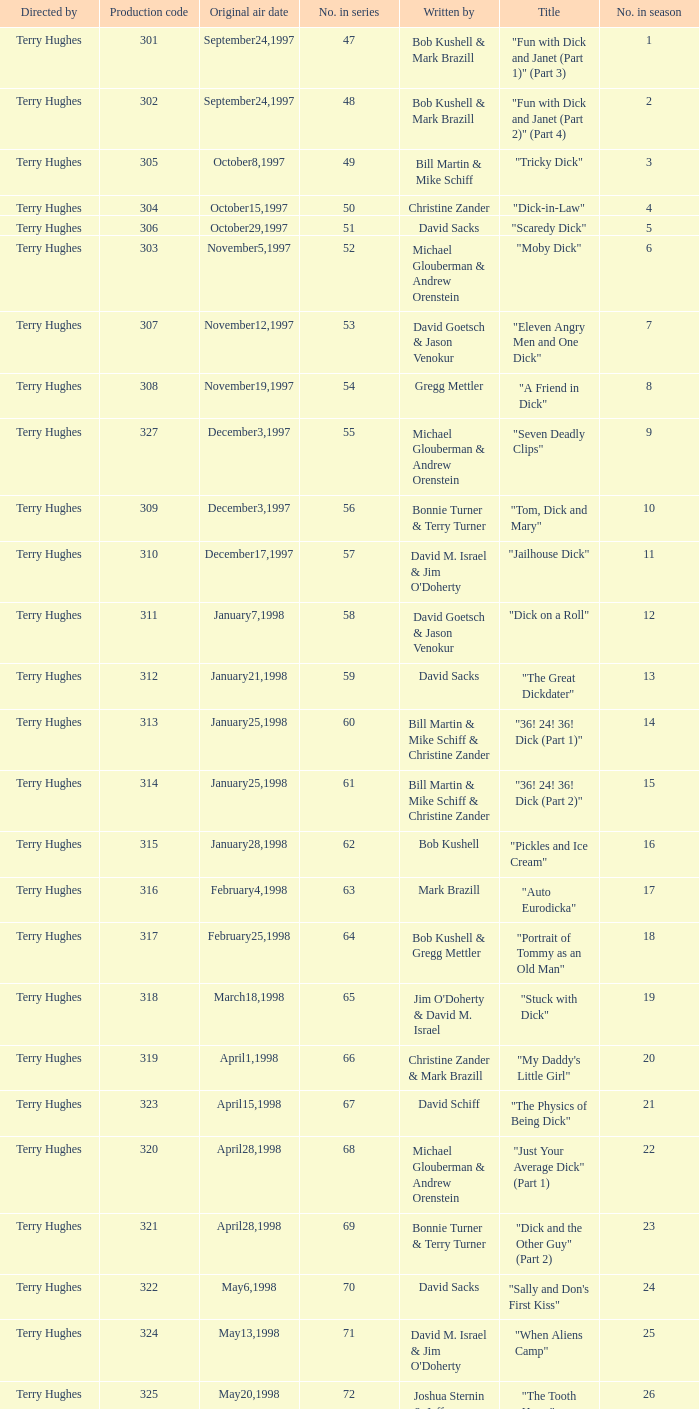Who were the writers of the episode titled "Tricky Dick"? Bill Martin & Mike Schiff. Can you give me this table as a dict? {'header': ['Directed by', 'Production code', 'Original air date', 'No. in series', 'Written by', 'Title', 'No. in season'], 'rows': [['Terry Hughes', '301', 'September24,1997', '47', 'Bob Kushell & Mark Brazill', '"Fun with Dick and Janet (Part 1)" (Part 3)', '1'], ['Terry Hughes', '302', 'September24,1997', '48', 'Bob Kushell & Mark Brazill', '"Fun with Dick and Janet (Part 2)" (Part 4)', '2'], ['Terry Hughes', '305', 'October8,1997', '49', 'Bill Martin & Mike Schiff', '"Tricky Dick"', '3'], ['Terry Hughes', '304', 'October15,1997', '50', 'Christine Zander', '"Dick-in-Law"', '4'], ['Terry Hughes', '306', 'October29,1997', '51', 'David Sacks', '"Scaredy Dick"', '5'], ['Terry Hughes', '303', 'November5,1997', '52', 'Michael Glouberman & Andrew Orenstein', '"Moby Dick"', '6'], ['Terry Hughes', '307', 'November12,1997', '53', 'David Goetsch & Jason Venokur', '"Eleven Angry Men and One Dick"', '7'], ['Terry Hughes', '308', 'November19,1997', '54', 'Gregg Mettler', '"A Friend in Dick"', '8'], ['Terry Hughes', '327', 'December3,1997', '55', 'Michael Glouberman & Andrew Orenstein', '"Seven Deadly Clips"', '9'], ['Terry Hughes', '309', 'December3,1997', '56', 'Bonnie Turner & Terry Turner', '"Tom, Dick and Mary"', '10'], ['Terry Hughes', '310', 'December17,1997', '57', "David M. Israel & Jim O'Doherty", '"Jailhouse Dick"', '11'], ['Terry Hughes', '311', 'January7,1998', '58', 'David Goetsch & Jason Venokur', '"Dick on a Roll"', '12'], ['Terry Hughes', '312', 'January21,1998', '59', 'David Sacks', '"The Great Dickdater"', '13'], ['Terry Hughes', '313', 'January25,1998', '60', 'Bill Martin & Mike Schiff & Christine Zander', '"36! 24! 36! Dick (Part 1)"', '14'], ['Terry Hughes', '314', 'January25,1998', '61', 'Bill Martin & Mike Schiff & Christine Zander', '"36! 24! 36! Dick (Part 2)"', '15'], ['Terry Hughes', '315', 'January28,1998', '62', 'Bob Kushell', '"Pickles and Ice Cream"', '16'], ['Terry Hughes', '316', 'February4,1998', '63', 'Mark Brazill', '"Auto Eurodicka"', '17'], ['Terry Hughes', '317', 'February25,1998', '64', 'Bob Kushell & Gregg Mettler', '"Portrait of Tommy as an Old Man"', '18'], ['Terry Hughes', '318', 'March18,1998', '65', "Jim O'Doherty & David M. Israel", '"Stuck with Dick"', '19'], ['Terry Hughes', '319', 'April1,1998', '66', 'Christine Zander & Mark Brazill', '"My Daddy\'s Little Girl"', '20'], ['Terry Hughes', '323', 'April15,1998', '67', 'David Schiff', '"The Physics of Being Dick"', '21'], ['Terry Hughes', '320', 'April28,1998', '68', 'Michael Glouberman & Andrew Orenstein', '"Just Your Average Dick" (Part 1)', '22'], ['Terry Hughes', '321', 'April28,1998', '69', 'Bonnie Turner & Terry Turner', '"Dick and the Other Guy" (Part 2)', '23'], ['Terry Hughes', '322', 'May6,1998', '70', 'David Sacks', '"Sally and Don\'s First Kiss"', '24'], ['Terry Hughes', '324', 'May13,1998', '71', "David M. Israel & Jim O'Doherty", '"When Aliens Camp"', '25'], ['Terry Hughes', '325', 'May20,1998', '72', 'Joshua Sternin & Jeffrey Ventimilia', '"The Tooth Harry"', '26']]} 